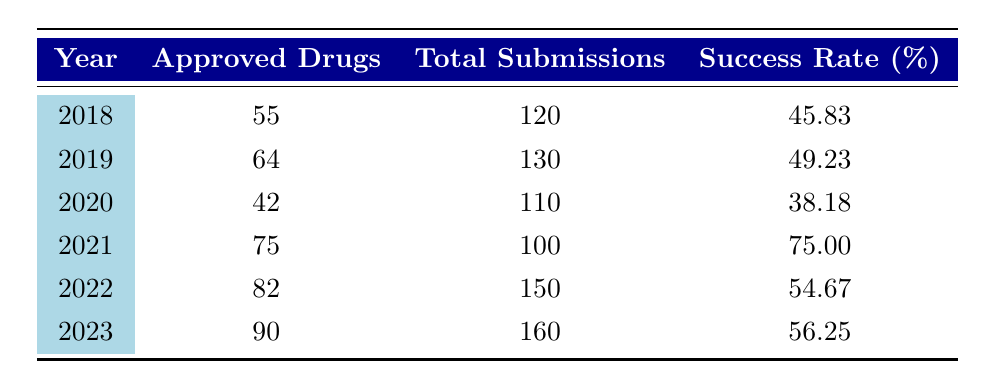What was the success rate of drug approvals in 2020? Referring to the table, the data entry for the year 2020 shows a success rate of 38.18%.
Answer: 38.18 Which year had the highest number of approved drugs? By examining the approved drugs column, 2023 shows the highest number of approved drugs with a total of 90.
Answer: 2023 What was the average success rate from 2018 to 2023? To calculate the average, sum the success rates (45.83 + 49.23 + 38.18 + 75.00 + 54.67 + 56.25) = 319.16. There are 6 years, so the average is 319.16 / 6 ≈ 53.19.
Answer: 53.19 Did the success rate increase in 2021 compared to 2020? Comparing the success rates, in 2020 it was 38.18%, and in 2021 it rose to 75.00%. Therefore, yes, the success rate increased.
Answer: Yes What is the total number of submissions across all years? Summing the total submissions (120 + 130 + 110 + 100 + 150 + 160) gives 870 total submissions across the years.
Answer: 870 What was the change in the number of approved drugs from 2019 to 2022? The number of approved drugs in 2019 is 64 and in 2022 is 82. The change is 82 - 64 = 18, indicating an increase of 18.
Answer: 18 Is the success rate in 2021 the highest among all years? Upon reviewing the success rates, 2021 has 75.00%, which is higher than all other years listed. Therefore, yes.
Answer: Yes What year experienced the lowest success rate among the years displayed? Looking at the success rates, 2020 has the lowest at 38.18%.
Answer: 2020 How does the success rate in 2023 compare with the average success rate from 2018 to 2022? The average from 2018 to 2022 is approximately 53.19%, while the success rate in 2023 is 56.25%. Since 56.25% > 53.19%, it is higher.
Answer: Higher 